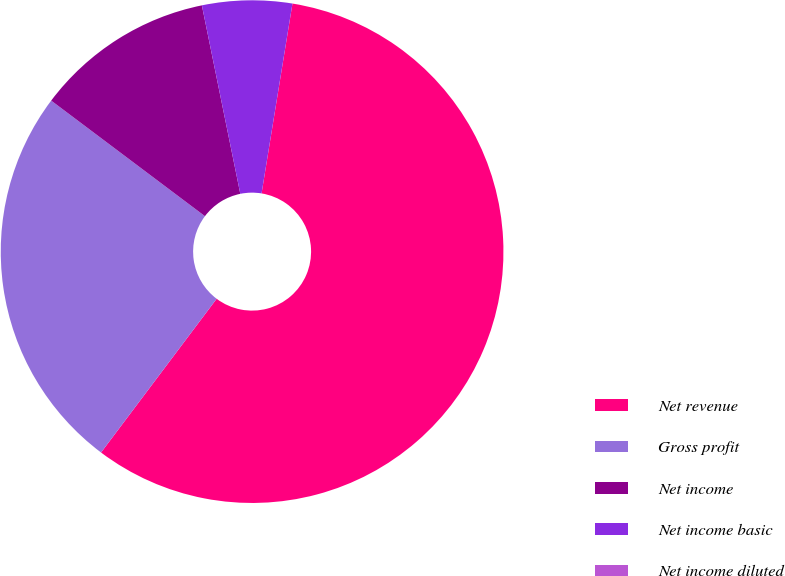Convert chart. <chart><loc_0><loc_0><loc_500><loc_500><pie_chart><fcel>Net revenue<fcel>Gross profit<fcel>Net income<fcel>Net income basic<fcel>Net income diluted<nl><fcel>57.7%<fcel>25.0%<fcel>11.54%<fcel>5.77%<fcel>0.0%<nl></chart> 